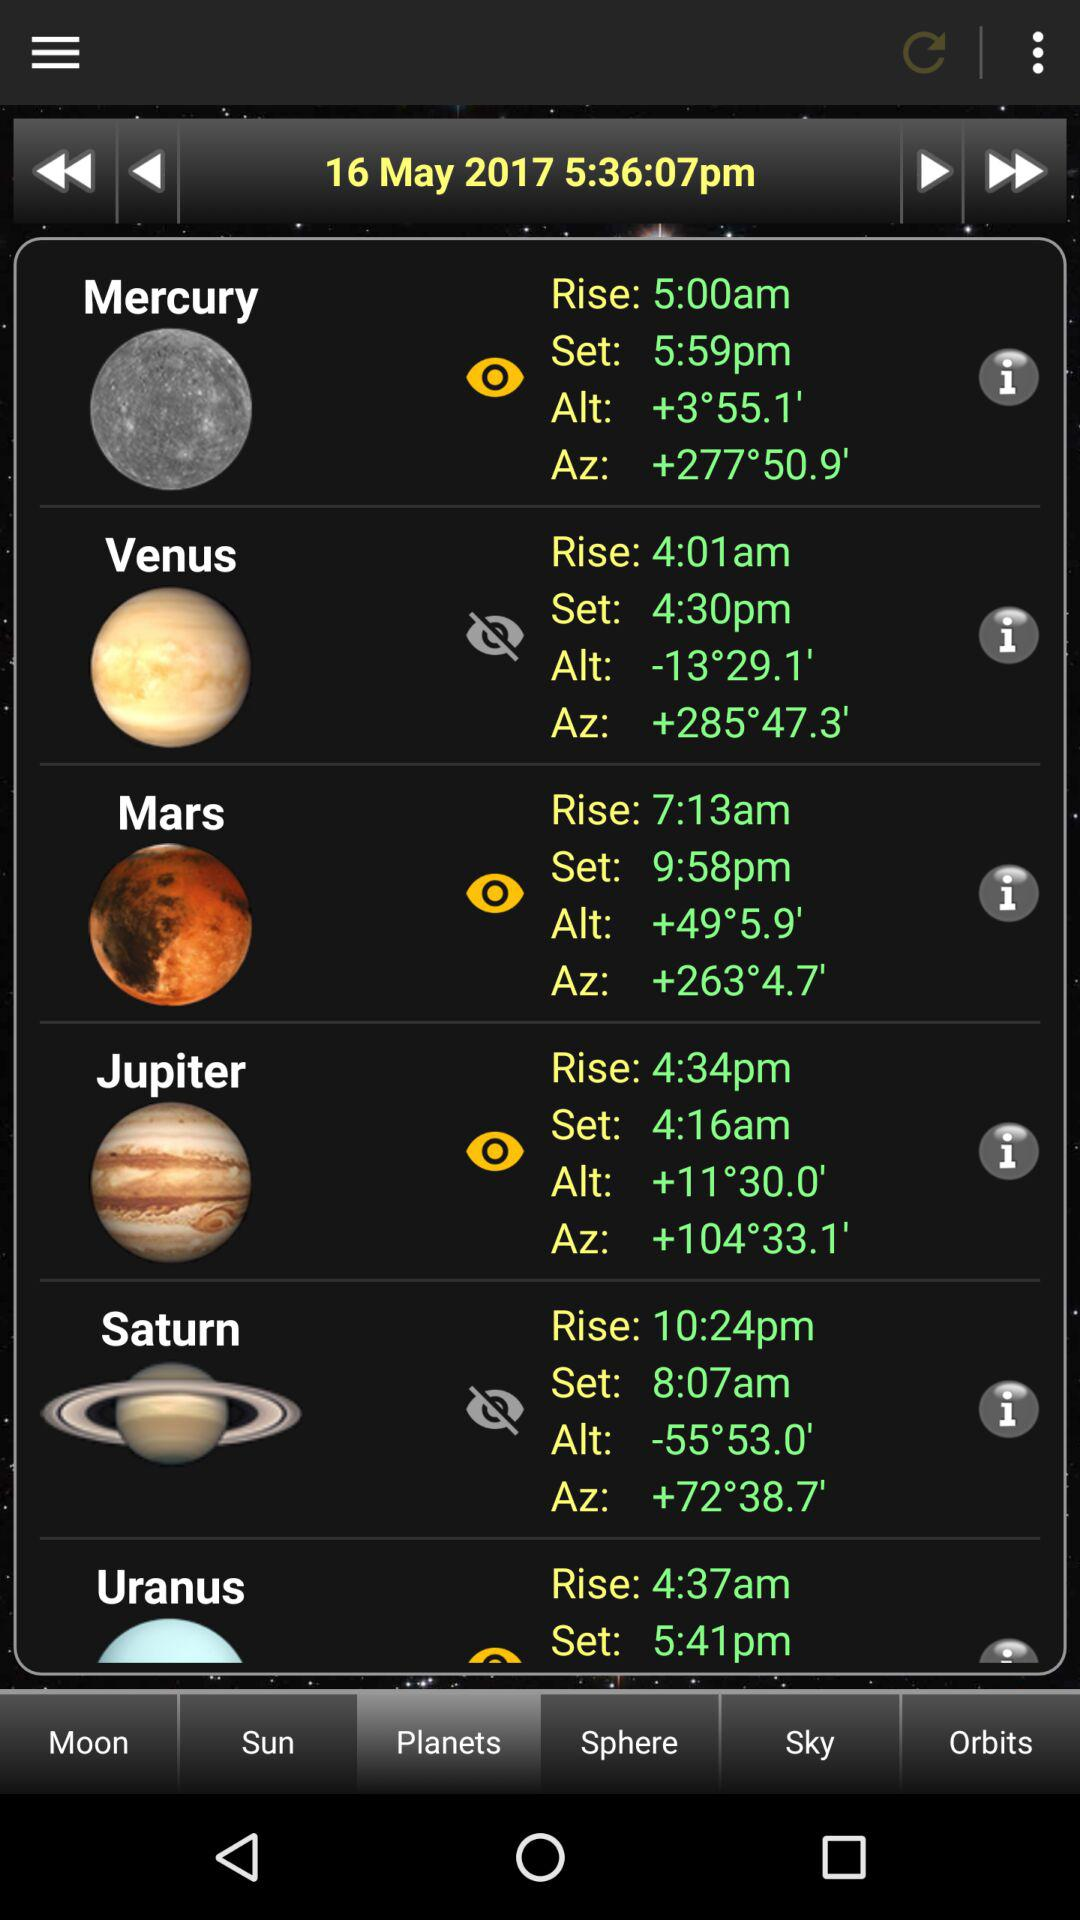What is the altitude of Jupiter? The altitude of Jupiter is +11°30.0'. 